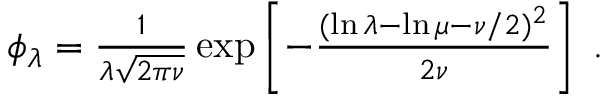Convert formula to latex. <formula><loc_0><loc_0><loc_500><loc_500>\begin{array} { r } { \phi _ { \lambda } = \frac { 1 } { \lambda \sqrt { 2 \pi \nu } } \exp \left [ - \frac { ( \ln \lambda - \ln \mu - \nu / 2 ) ^ { 2 } } { 2 \nu } \right ] \, . } \end{array}</formula> 